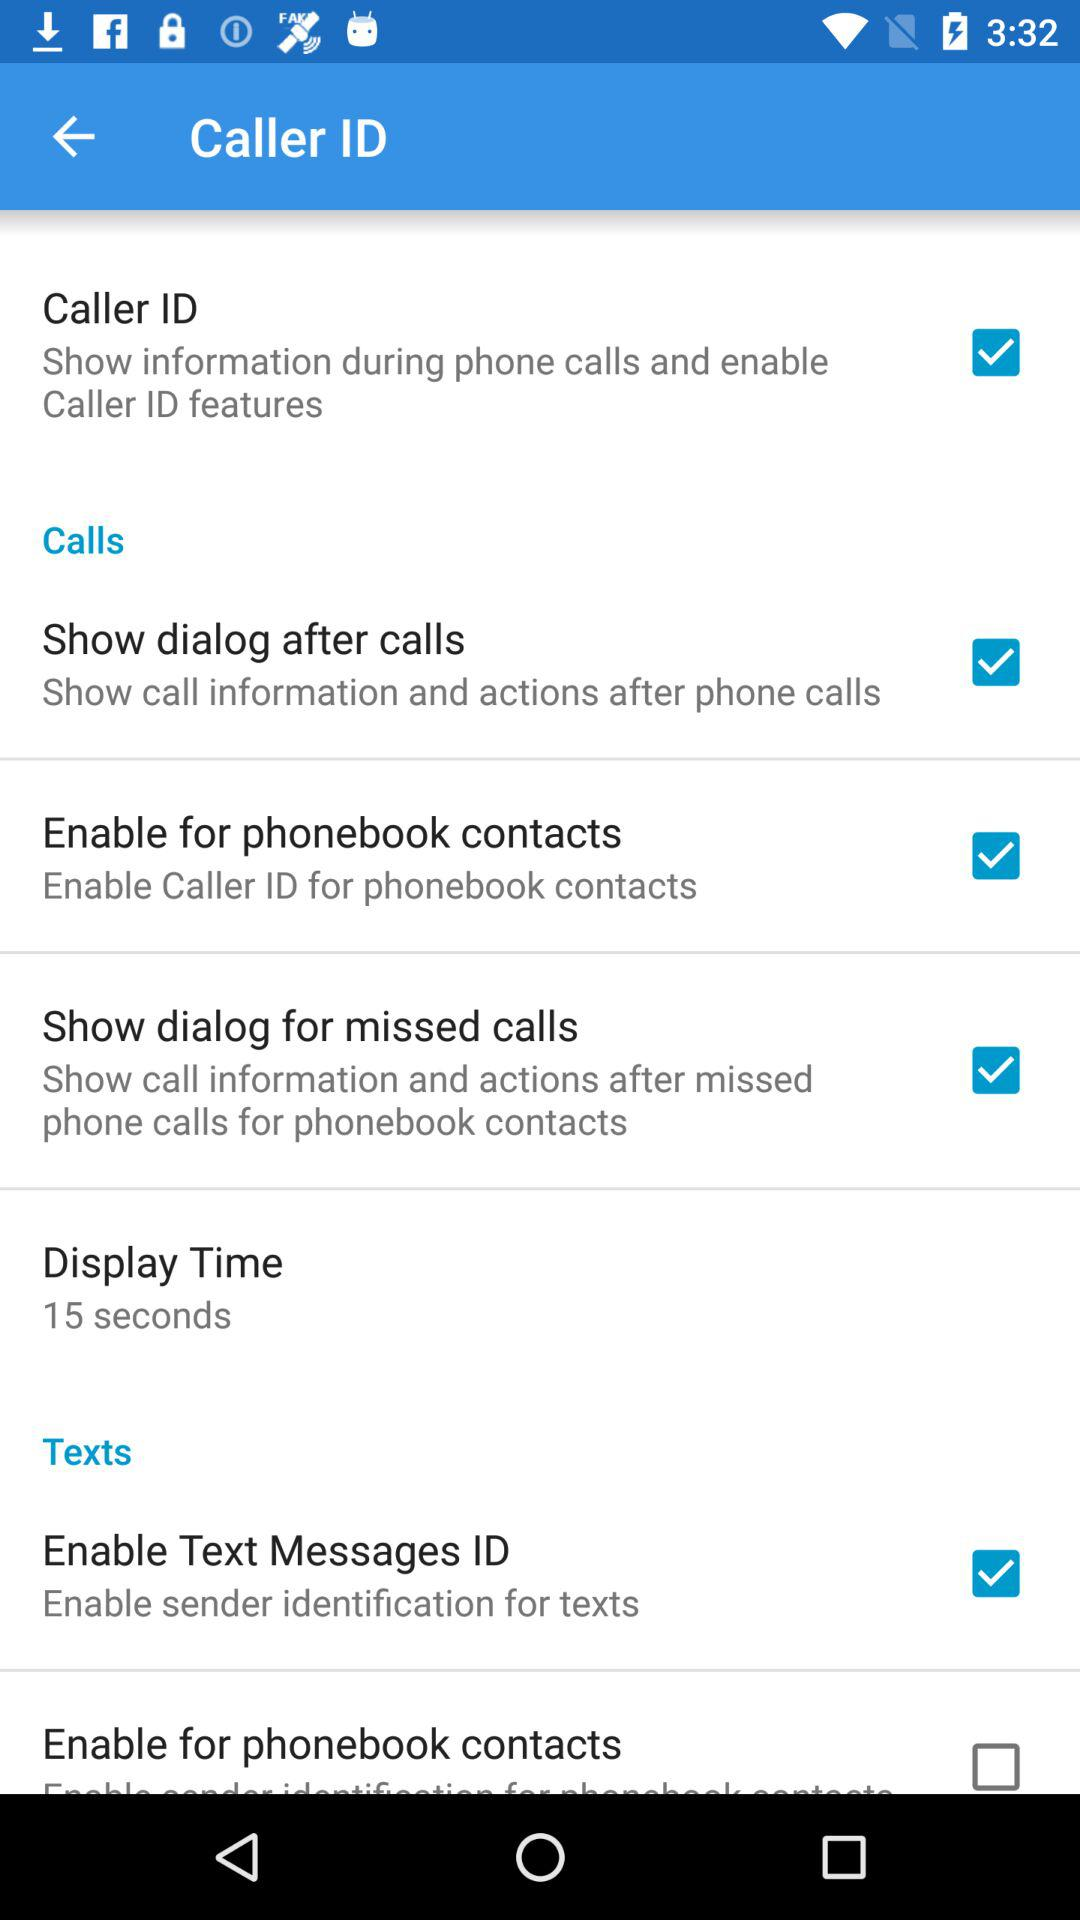What is the duration of display time? The duration is 15 seconds. 